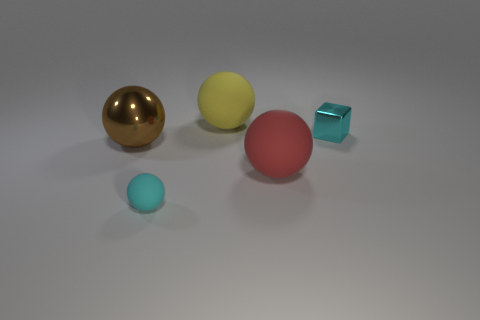Subtract all big yellow balls. How many balls are left? 3 Subtract all yellow balls. How many balls are left? 3 Subtract 1 spheres. How many spheres are left? 3 Add 3 cyan metal things. How many objects exist? 8 Subtract all cubes. How many objects are left? 4 Subtract all brown cubes. Subtract all brown balls. How many cubes are left? 1 Subtract all blue metallic cylinders. Subtract all metallic balls. How many objects are left? 4 Add 5 small cyan shiny blocks. How many small cyan shiny blocks are left? 6 Add 2 brown shiny cylinders. How many brown shiny cylinders exist? 2 Subtract 0 blue blocks. How many objects are left? 5 